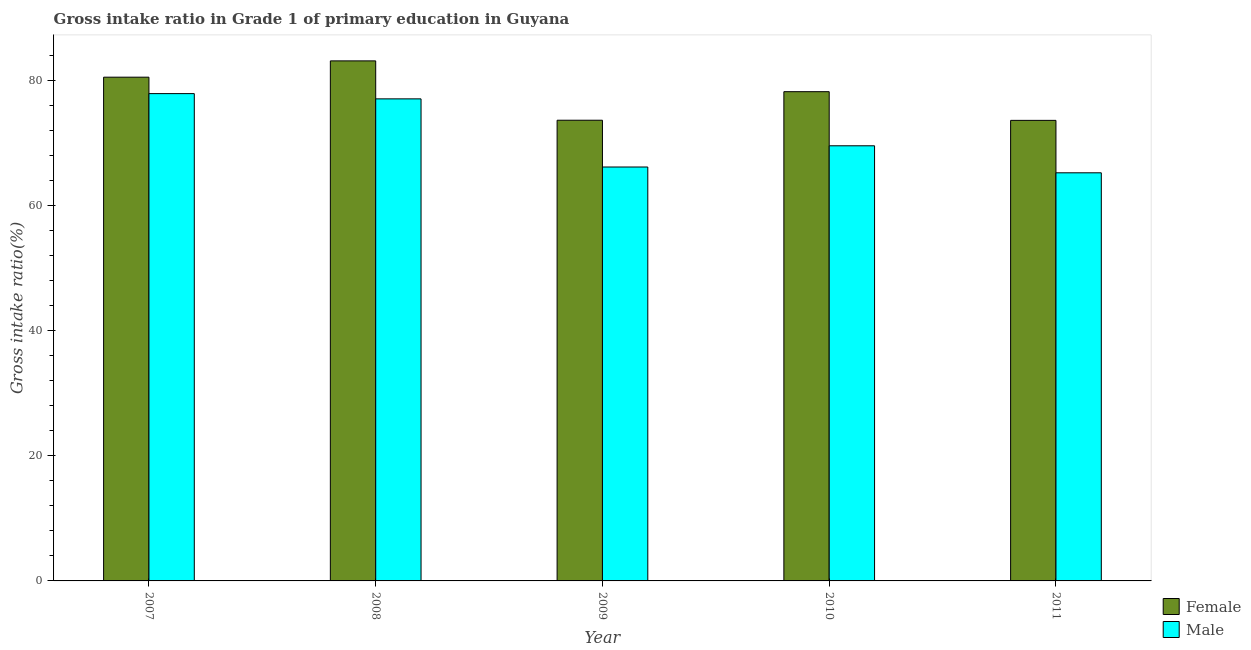How many different coloured bars are there?
Keep it short and to the point. 2. How many groups of bars are there?
Give a very brief answer. 5. Are the number of bars on each tick of the X-axis equal?
Your response must be concise. Yes. How many bars are there on the 4th tick from the right?
Ensure brevity in your answer.  2. In how many cases, is the number of bars for a given year not equal to the number of legend labels?
Offer a terse response. 0. What is the gross intake ratio(male) in 2009?
Provide a succinct answer. 66.14. Across all years, what is the maximum gross intake ratio(female)?
Provide a short and direct response. 83.1. Across all years, what is the minimum gross intake ratio(female)?
Make the answer very short. 73.59. In which year was the gross intake ratio(male) minimum?
Your answer should be very brief. 2011. What is the total gross intake ratio(female) in the graph?
Give a very brief answer. 388.97. What is the difference between the gross intake ratio(female) in 2007 and that in 2008?
Provide a succinct answer. -2.61. What is the difference between the gross intake ratio(male) in 2011 and the gross intake ratio(female) in 2010?
Ensure brevity in your answer.  -4.32. What is the average gross intake ratio(female) per year?
Keep it short and to the point. 77.79. In the year 2007, what is the difference between the gross intake ratio(female) and gross intake ratio(male)?
Offer a very short reply. 0. In how many years, is the gross intake ratio(female) greater than 48 %?
Your answer should be compact. 5. What is the ratio of the gross intake ratio(male) in 2009 to that in 2010?
Ensure brevity in your answer.  0.95. What is the difference between the highest and the second highest gross intake ratio(male)?
Keep it short and to the point. 0.84. What is the difference between the highest and the lowest gross intake ratio(female)?
Keep it short and to the point. 9.5. Is the sum of the gross intake ratio(female) in 2008 and 2009 greater than the maximum gross intake ratio(male) across all years?
Offer a terse response. Yes. How many bars are there?
Your answer should be compact. 10. Are all the bars in the graph horizontal?
Your answer should be very brief. No. How many years are there in the graph?
Keep it short and to the point. 5. Are the values on the major ticks of Y-axis written in scientific E-notation?
Provide a succinct answer. No. What is the title of the graph?
Keep it short and to the point. Gross intake ratio in Grade 1 of primary education in Guyana. What is the label or title of the Y-axis?
Make the answer very short. Gross intake ratio(%). What is the Gross intake ratio(%) of Female in 2007?
Your response must be concise. 80.49. What is the Gross intake ratio(%) in Male in 2007?
Provide a succinct answer. 77.87. What is the Gross intake ratio(%) of Female in 2008?
Provide a short and direct response. 83.1. What is the Gross intake ratio(%) of Male in 2008?
Your response must be concise. 77.03. What is the Gross intake ratio(%) of Female in 2009?
Make the answer very short. 73.61. What is the Gross intake ratio(%) of Male in 2009?
Provide a short and direct response. 66.14. What is the Gross intake ratio(%) of Female in 2010?
Provide a short and direct response. 78.17. What is the Gross intake ratio(%) in Male in 2010?
Give a very brief answer. 69.53. What is the Gross intake ratio(%) of Female in 2011?
Your answer should be compact. 73.59. What is the Gross intake ratio(%) in Male in 2011?
Ensure brevity in your answer.  65.21. Across all years, what is the maximum Gross intake ratio(%) of Female?
Keep it short and to the point. 83.1. Across all years, what is the maximum Gross intake ratio(%) in Male?
Offer a very short reply. 77.87. Across all years, what is the minimum Gross intake ratio(%) of Female?
Offer a very short reply. 73.59. Across all years, what is the minimum Gross intake ratio(%) in Male?
Offer a terse response. 65.21. What is the total Gross intake ratio(%) of Female in the graph?
Your response must be concise. 388.97. What is the total Gross intake ratio(%) of Male in the graph?
Offer a very short reply. 355.77. What is the difference between the Gross intake ratio(%) in Female in 2007 and that in 2008?
Provide a short and direct response. -2.61. What is the difference between the Gross intake ratio(%) in Male in 2007 and that in 2008?
Provide a succinct answer. 0.84. What is the difference between the Gross intake ratio(%) in Female in 2007 and that in 2009?
Make the answer very short. 6.88. What is the difference between the Gross intake ratio(%) in Male in 2007 and that in 2009?
Provide a succinct answer. 11.73. What is the difference between the Gross intake ratio(%) in Female in 2007 and that in 2010?
Your answer should be compact. 2.32. What is the difference between the Gross intake ratio(%) of Male in 2007 and that in 2010?
Offer a very short reply. 8.34. What is the difference between the Gross intake ratio(%) of Female in 2007 and that in 2011?
Offer a very short reply. 6.9. What is the difference between the Gross intake ratio(%) of Male in 2007 and that in 2011?
Ensure brevity in your answer.  12.65. What is the difference between the Gross intake ratio(%) in Female in 2008 and that in 2009?
Provide a succinct answer. 9.48. What is the difference between the Gross intake ratio(%) of Male in 2008 and that in 2009?
Your response must be concise. 10.89. What is the difference between the Gross intake ratio(%) of Female in 2008 and that in 2010?
Keep it short and to the point. 4.92. What is the difference between the Gross intake ratio(%) in Male in 2008 and that in 2010?
Provide a succinct answer. 7.5. What is the difference between the Gross intake ratio(%) in Female in 2008 and that in 2011?
Make the answer very short. 9.51. What is the difference between the Gross intake ratio(%) of Male in 2008 and that in 2011?
Offer a very short reply. 11.81. What is the difference between the Gross intake ratio(%) in Female in 2009 and that in 2010?
Make the answer very short. -4.56. What is the difference between the Gross intake ratio(%) in Male in 2009 and that in 2010?
Keep it short and to the point. -3.39. What is the difference between the Gross intake ratio(%) of Female in 2009 and that in 2011?
Your response must be concise. 0.02. What is the difference between the Gross intake ratio(%) of Male in 2009 and that in 2011?
Give a very brief answer. 0.93. What is the difference between the Gross intake ratio(%) in Female in 2010 and that in 2011?
Give a very brief answer. 4.58. What is the difference between the Gross intake ratio(%) in Male in 2010 and that in 2011?
Your response must be concise. 4.32. What is the difference between the Gross intake ratio(%) in Female in 2007 and the Gross intake ratio(%) in Male in 2008?
Provide a short and direct response. 3.47. What is the difference between the Gross intake ratio(%) of Female in 2007 and the Gross intake ratio(%) of Male in 2009?
Give a very brief answer. 14.35. What is the difference between the Gross intake ratio(%) of Female in 2007 and the Gross intake ratio(%) of Male in 2010?
Provide a short and direct response. 10.96. What is the difference between the Gross intake ratio(%) in Female in 2007 and the Gross intake ratio(%) in Male in 2011?
Provide a short and direct response. 15.28. What is the difference between the Gross intake ratio(%) of Female in 2008 and the Gross intake ratio(%) of Male in 2009?
Your answer should be compact. 16.96. What is the difference between the Gross intake ratio(%) of Female in 2008 and the Gross intake ratio(%) of Male in 2010?
Your answer should be very brief. 13.57. What is the difference between the Gross intake ratio(%) of Female in 2008 and the Gross intake ratio(%) of Male in 2011?
Your response must be concise. 17.88. What is the difference between the Gross intake ratio(%) of Female in 2009 and the Gross intake ratio(%) of Male in 2010?
Your answer should be compact. 4.09. What is the difference between the Gross intake ratio(%) of Female in 2009 and the Gross intake ratio(%) of Male in 2011?
Keep it short and to the point. 8.4. What is the difference between the Gross intake ratio(%) in Female in 2010 and the Gross intake ratio(%) in Male in 2011?
Provide a short and direct response. 12.96. What is the average Gross intake ratio(%) of Female per year?
Offer a very short reply. 77.79. What is the average Gross intake ratio(%) of Male per year?
Provide a succinct answer. 71.15. In the year 2007, what is the difference between the Gross intake ratio(%) of Female and Gross intake ratio(%) of Male?
Keep it short and to the point. 2.63. In the year 2008, what is the difference between the Gross intake ratio(%) in Female and Gross intake ratio(%) in Male?
Provide a succinct answer. 6.07. In the year 2009, what is the difference between the Gross intake ratio(%) of Female and Gross intake ratio(%) of Male?
Your answer should be very brief. 7.48. In the year 2010, what is the difference between the Gross intake ratio(%) in Female and Gross intake ratio(%) in Male?
Ensure brevity in your answer.  8.65. In the year 2011, what is the difference between the Gross intake ratio(%) of Female and Gross intake ratio(%) of Male?
Provide a short and direct response. 8.38. What is the ratio of the Gross intake ratio(%) in Female in 2007 to that in 2008?
Offer a terse response. 0.97. What is the ratio of the Gross intake ratio(%) in Male in 2007 to that in 2008?
Your answer should be very brief. 1.01. What is the ratio of the Gross intake ratio(%) of Female in 2007 to that in 2009?
Ensure brevity in your answer.  1.09. What is the ratio of the Gross intake ratio(%) in Male in 2007 to that in 2009?
Provide a short and direct response. 1.18. What is the ratio of the Gross intake ratio(%) in Female in 2007 to that in 2010?
Offer a terse response. 1.03. What is the ratio of the Gross intake ratio(%) of Male in 2007 to that in 2010?
Provide a short and direct response. 1.12. What is the ratio of the Gross intake ratio(%) in Female in 2007 to that in 2011?
Offer a terse response. 1.09. What is the ratio of the Gross intake ratio(%) in Male in 2007 to that in 2011?
Ensure brevity in your answer.  1.19. What is the ratio of the Gross intake ratio(%) of Female in 2008 to that in 2009?
Offer a terse response. 1.13. What is the ratio of the Gross intake ratio(%) of Male in 2008 to that in 2009?
Ensure brevity in your answer.  1.16. What is the ratio of the Gross intake ratio(%) of Female in 2008 to that in 2010?
Offer a terse response. 1.06. What is the ratio of the Gross intake ratio(%) of Male in 2008 to that in 2010?
Keep it short and to the point. 1.11. What is the ratio of the Gross intake ratio(%) in Female in 2008 to that in 2011?
Provide a succinct answer. 1.13. What is the ratio of the Gross intake ratio(%) in Male in 2008 to that in 2011?
Offer a terse response. 1.18. What is the ratio of the Gross intake ratio(%) of Female in 2009 to that in 2010?
Keep it short and to the point. 0.94. What is the ratio of the Gross intake ratio(%) of Male in 2009 to that in 2010?
Your answer should be compact. 0.95. What is the ratio of the Gross intake ratio(%) in Female in 2009 to that in 2011?
Your answer should be compact. 1. What is the ratio of the Gross intake ratio(%) of Male in 2009 to that in 2011?
Give a very brief answer. 1.01. What is the ratio of the Gross intake ratio(%) of Female in 2010 to that in 2011?
Offer a terse response. 1.06. What is the ratio of the Gross intake ratio(%) in Male in 2010 to that in 2011?
Your answer should be compact. 1.07. What is the difference between the highest and the second highest Gross intake ratio(%) in Female?
Provide a succinct answer. 2.61. What is the difference between the highest and the second highest Gross intake ratio(%) of Male?
Your answer should be compact. 0.84. What is the difference between the highest and the lowest Gross intake ratio(%) in Female?
Ensure brevity in your answer.  9.51. What is the difference between the highest and the lowest Gross intake ratio(%) of Male?
Keep it short and to the point. 12.65. 